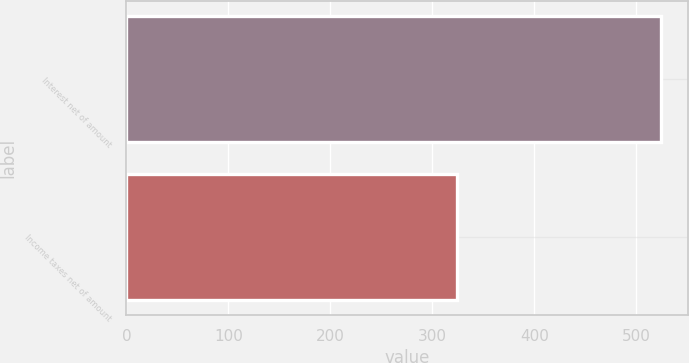<chart> <loc_0><loc_0><loc_500><loc_500><bar_chart><fcel>Interest net of amount<fcel>Income taxes net of amount<nl><fcel>524<fcel>324<nl></chart> 